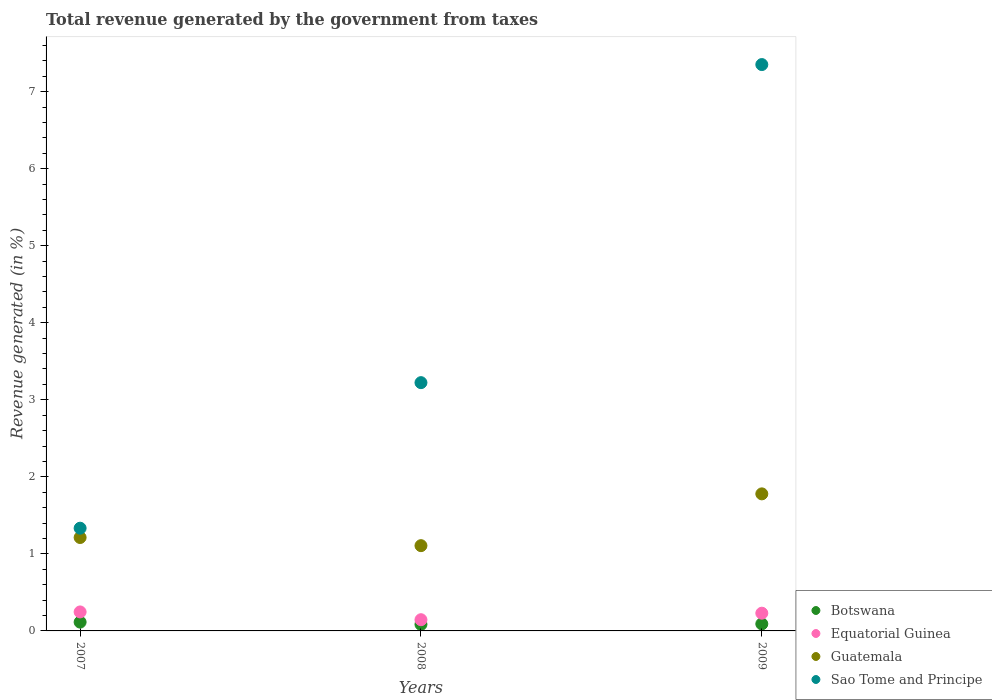Is the number of dotlines equal to the number of legend labels?
Ensure brevity in your answer.  Yes. What is the total revenue generated in Equatorial Guinea in 2008?
Your answer should be compact. 0.15. Across all years, what is the maximum total revenue generated in Equatorial Guinea?
Give a very brief answer. 0.25. Across all years, what is the minimum total revenue generated in Sao Tome and Principe?
Your answer should be very brief. 1.33. In which year was the total revenue generated in Sao Tome and Principe maximum?
Your answer should be very brief. 2009. What is the total total revenue generated in Botswana in the graph?
Offer a terse response. 0.29. What is the difference between the total revenue generated in Botswana in 2008 and that in 2009?
Give a very brief answer. -0.01. What is the difference between the total revenue generated in Guatemala in 2007 and the total revenue generated in Equatorial Guinea in 2009?
Keep it short and to the point. 0.98. What is the average total revenue generated in Sao Tome and Principe per year?
Offer a very short reply. 3.97. In the year 2007, what is the difference between the total revenue generated in Sao Tome and Principe and total revenue generated in Botswana?
Your response must be concise. 1.22. What is the ratio of the total revenue generated in Equatorial Guinea in 2008 to that in 2009?
Make the answer very short. 0.63. Is the total revenue generated in Sao Tome and Principe in 2007 less than that in 2009?
Give a very brief answer. Yes. What is the difference between the highest and the second highest total revenue generated in Botswana?
Provide a succinct answer. 0.02. What is the difference between the highest and the lowest total revenue generated in Sao Tome and Principe?
Your response must be concise. 6.02. In how many years, is the total revenue generated in Equatorial Guinea greater than the average total revenue generated in Equatorial Guinea taken over all years?
Your answer should be very brief. 2. Is the sum of the total revenue generated in Guatemala in 2007 and 2009 greater than the maximum total revenue generated in Equatorial Guinea across all years?
Offer a terse response. Yes. Is it the case that in every year, the sum of the total revenue generated in Guatemala and total revenue generated in Sao Tome and Principe  is greater than the sum of total revenue generated in Equatorial Guinea and total revenue generated in Botswana?
Offer a very short reply. Yes. Is the total revenue generated in Sao Tome and Principe strictly greater than the total revenue generated in Botswana over the years?
Your response must be concise. Yes. What is the difference between two consecutive major ticks on the Y-axis?
Make the answer very short. 1. Where does the legend appear in the graph?
Offer a terse response. Bottom right. How many legend labels are there?
Make the answer very short. 4. What is the title of the graph?
Your response must be concise. Total revenue generated by the government from taxes. Does "Latin America(all income levels)" appear as one of the legend labels in the graph?
Keep it short and to the point. No. What is the label or title of the X-axis?
Give a very brief answer. Years. What is the label or title of the Y-axis?
Ensure brevity in your answer.  Revenue generated (in %). What is the Revenue generated (in %) in Botswana in 2007?
Give a very brief answer. 0.11. What is the Revenue generated (in %) of Equatorial Guinea in 2007?
Give a very brief answer. 0.25. What is the Revenue generated (in %) in Guatemala in 2007?
Ensure brevity in your answer.  1.21. What is the Revenue generated (in %) in Sao Tome and Principe in 2007?
Ensure brevity in your answer.  1.33. What is the Revenue generated (in %) in Botswana in 2008?
Keep it short and to the point. 0.08. What is the Revenue generated (in %) in Equatorial Guinea in 2008?
Offer a very short reply. 0.15. What is the Revenue generated (in %) of Guatemala in 2008?
Make the answer very short. 1.11. What is the Revenue generated (in %) of Sao Tome and Principe in 2008?
Offer a terse response. 3.22. What is the Revenue generated (in %) in Botswana in 2009?
Your response must be concise. 0.09. What is the Revenue generated (in %) in Equatorial Guinea in 2009?
Keep it short and to the point. 0.23. What is the Revenue generated (in %) in Guatemala in 2009?
Offer a very short reply. 1.78. What is the Revenue generated (in %) in Sao Tome and Principe in 2009?
Offer a very short reply. 7.35. Across all years, what is the maximum Revenue generated (in %) in Botswana?
Offer a terse response. 0.11. Across all years, what is the maximum Revenue generated (in %) in Equatorial Guinea?
Provide a short and direct response. 0.25. Across all years, what is the maximum Revenue generated (in %) in Guatemala?
Offer a terse response. 1.78. Across all years, what is the maximum Revenue generated (in %) of Sao Tome and Principe?
Your response must be concise. 7.35. Across all years, what is the minimum Revenue generated (in %) in Botswana?
Your answer should be very brief. 0.08. Across all years, what is the minimum Revenue generated (in %) of Equatorial Guinea?
Offer a very short reply. 0.15. Across all years, what is the minimum Revenue generated (in %) in Guatemala?
Make the answer very short. 1.11. Across all years, what is the minimum Revenue generated (in %) in Sao Tome and Principe?
Make the answer very short. 1.33. What is the total Revenue generated (in %) of Botswana in the graph?
Give a very brief answer. 0.29. What is the total Revenue generated (in %) of Equatorial Guinea in the graph?
Your response must be concise. 0.62. What is the total Revenue generated (in %) of Guatemala in the graph?
Give a very brief answer. 4.1. What is the total Revenue generated (in %) in Sao Tome and Principe in the graph?
Provide a succinct answer. 11.91. What is the difference between the Revenue generated (in %) of Botswana in 2007 and that in 2008?
Provide a succinct answer. 0.03. What is the difference between the Revenue generated (in %) in Equatorial Guinea in 2007 and that in 2008?
Your response must be concise. 0.1. What is the difference between the Revenue generated (in %) of Guatemala in 2007 and that in 2008?
Provide a short and direct response. 0.11. What is the difference between the Revenue generated (in %) in Sao Tome and Principe in 2007 and that in 2008?
Offer a terse response. -1.89. What is the difference between the Revenue generated (in %) of Botswana in 2007 and that in 2009?
Make the answer very short. 0.02. What is the difference between the Revenue generated (in %) in Equatorial Guinea in 2007 and that in 2009?
Keep it short and to the point. 0.02. What is the difference between the Revenue generated (in %) of Guatemala in 2007 and that in 2009?
Make the answer very short. -0.57. What is the difference between the Revenue generated (in %) in Sao Tome and Principe in 2007 and that in 2009?
Provide a short and direct response. -6.02. What is the difference between the Revenue generated (in %) of Botswana in 2008 and that in 2009?
Make the answer very short. -0.01. What is the difference between the Revenue generated (in %) of Equatorial Guinea in 2008 and that in 2009?
Give a very brief answer. -0.08. What is the difference between the Revenue generated (in %) of Guatemala in 2008 and that in 2009?
Offer a terse response. -0.67. What is the difference between the Revenue generated (in %) of Sao Tome and Principe in 2008 and that in 2009?
Provide a short and direct response. -4.13. What is the difference between the Revenue generated (in %) of Botswana in 2007 and the Revenue generated (in %) of Equatorial Guinea in 2008?
Your response must be concise. -0.03. What is the difference between the Revenue generated (in %) in Botswana in 2007 and the Revenue generated (in %) in Guatemala in 2008?
Provide a succinct answer. -0.99. What is the difference between the Revenue generated (in %) of Botswana in 2007 and the Revenue generated (in %) of Sao Tome and Principe in 2008?
Your answer should be compact. -3.11. What is the difference between the Revenue generated (in %) in Equatorial Guinea in 2007 and the Revenue generated (in %) in Guatemala in 2008?
Ensure brevity in your answer.  -0.86. What is the difference between the Revenue generated (in %) in Equatorial Guinea in 2007 and the Revenue generated (in %) in Sao Tome and Principe in 2008?
Offer a terse response. -2.98. What is the difference between the Revenue generated (in %) in Guatemala in 2007 and the Revenue generated (in %) in Sao Tome and Principe in 2008?
Offer a very short reply. -2.01. What is the difference between the Revenue generated (in %) in Botswana in 2007 and the Revenue generated (in %) in Equatorial Guinea in 2009?
Make the answer very short. -0.12. What is the difference between the Revenue generated (in %) of Botswana in 2007 and the Revenue generated (in %) of Guatemala in 2009?
Your response must be concise. -1.66. What is the difference between the Revenue generated (in %) in Botswana in 2007 and the Revenue generated (in %) in Sao Tome and Principe in 2009?
Make the answer very short. -7.24. What is the difference between the Revenue generated (in %) in Equatorial Guinea in 2007 and the Revenue generated (in %) in Guatemala in 2009?
Offer a very short reply. -1.53. What is the difference between the Revenue generated (in %) in Equatorial Guinea in 2007 and the Revenue generated (in %) in Sao Tome and Principe in 2009?
Provide a succinct answer. -7.1. What is the difference between the Revenue generated (in %) of Guatemala in 2007 and the Revenue generated (in %) of Sao Tome and Principe in 2009?
Offer a very short reply. -6.14. What is the difference between the Revenue generated (in %) in Botswana in 2008 and the Revenue generated (in %) in Equatorial Guinea in 2009?
Your response must be concise. -0.15. What is the difference between the Revenue generated (in %) in Botswana in 2008 and the Revenue generated (in %) in Guatemala in 2009?
Your answer should be compact. -1.69. What is the difference between the Revenue generated (in %) in Botswana in 2008 and the Revenue generated (in %) in Sao Tome and Principe in 2009?
Offer a very short reply. -7.27. What is the difference between the Revenue generated (in %) of Equatorial Guinea in 2008 and the Revenue generated (in %) of Guatemala in 2009?
Give a very brief answer. -1.63. What is the difference between the Revenue generated (in %) in Equatorial Guinea in 2008 and the Revenue generated (in %) in Sao Tome and Principe in 2009?
Offer a very short reply. -7.21. What is the difference between the Revenue generated (in %) in Guatemala in 2008 and the Revenue generated (in %) in Sao Tome and Principe in 2009?
Give a very brief answer. -6.24. What is the average Revenue generated (in %) in Botswana per year?
Your answer should be compact. 0.1. What is the average Revenue generated (in %) of Equatorial Guinea per year?
Your answer should be compact. 0.21. What is the average Revenue generated (in %) of Guatemala per year?
Ensure brevity in your answer.  1.37. What is the average Revenue generated (in %) in Sao Tome and Principe per year?
Your answer should be compact. 3.97. In the year 2007, what is the difference between the Revenue generated (in %) of Botswana and Revenue generated (in %) of Equatorial Guinea?
Provide a succinct answer. -0.13. In the year 2007, what is the difference between the Revenue generated (in %) in Botswana and Revenue generated (in %) in Guatemala?
Keep it short and to the point. -1.1. In the year 2007, what is the difference between the Revenue generated (in %) in Botswana and Revenue generated (in %) in Sao Tome and Principe?
Your answer should be compact. -1.22. In the year 2007, what is the difference between the Revenue generated (in %) of Equatorial Guinea and Revenue generated (in %) of Guatemala?
Your answer should be compact. -0.97. In the year 2007, what is the difference between the Revenue generated (in %) of Equatorial Guinea and Revenue generated (in %) of Sao Tome and Principe?
Make the answer very short. -1.09. In the year 2007, what is the difference between the Revenue generated (in %) of Guatemala and Revenue generated (in %) of Sao Tome and Principe?
Ensure brevity in your answer.  -0.12. In the year 2008, what is the difference between the Revenue generated (in %) of Botswana and Revenue generated (in %) of Equatorial Guinea?
Offer a terse response. -0.06. In the year 2008, what is the difference between the Revenue generated (in %) in Botswana and Revenue generated (in %) in Guatemala?
Offer a very short reply. -1.02. In the year 2008, what is the difference between the Revenue generated (in %) of Botswana and Revenue generated (in %) of Sao Tome and Principe?
Your answer should be very brief. -3.14. In the year 2008, what is the difference between the Revenue generated (in %) of Equatorial Guinea and Revenue generated (in %) of Guatemala?
Offer a very short reply. -0.96. In the year 2008, what is the difference between the Revenue generated (in %) in Equatorial Guinea and Revenue generated (in %) in Sao Tome and Principe?
Make the answer very short. -3.08. In the year 2008, what is the difference between the Revenue generated (in %) of Guatemala and Revenue generated (in %) of Sao Tome and Principe?
Ensure brevity in your answer.  -2.12. In the year 2009, what is the difference between the Revenue generated (in %) in Botswana and Revenue generated (in %) in Equatorial Guinea?
Your response must be concise. -0.14. In the year 2009, what is the difference between the Revenue generated (in %) of Botswana and Revenue generated (in %) of Guatemala?
Keep it short and to the point. -1.69. In the year 2009, what is the difference between the Revenue generated (in %) in Botswana and Revenue generated (in %) in Sao Tome and Principe?
Offer a terse response. -7.26. In the year 2009, what is the difference between the Revenue generated (in %) in Equatorial Guinea and Revenue generated (in %) in Guatemala?
Your answer should be compact. -1.55. In the year 2009, what is the difference between the Revenue generated (in %) in Equatorial Guinea and Revenue generated (in %) in Sao Tome and Principe?
Provide a succinct answer. -7.12. In the year 2009, what is the difference between the Revenue generated (in %) in Guatemala and Revenue generated (in %) in Sao Tome and Principe?
Offer a very short reply. -5.57. What is the ratio of the Revenue generated (in %) of Botswana in 2007 to that in 2008?
Offer a very short reply. 1.35. What is the ratio of the Revenue generated (in %) in Equatorial Guinea in 2007 to that in 2008?
Keep it short and to the point. 1.69. What is the ratio of the Revenue generated (in %) in Guatemala in 2007 to that in 2008?
Provide a succinct answer. 1.1. What is the ratio of the Revenue generated (in %) of Sao Tome and Principe in 2007 to that in 2008?
Give a very brief answer. 0.41. What is the ratio of the Revenue generated (in %) in Botswana in 2007 to that in 2009?
Provide a succinct answer. 1.25. What is the ratio of the Revenue generated (in %) of Equatorial Guinea in 2007 to that in 2009?
Keep it short and to the point. 1.07. What is the ratio of the Revenue generated (in %) in Guatemala in 2007 to that in 2009?
Ensure brevity in your answer.  0.68. What is the ratio of the Revenue generated (in %) in Sao Tome and Principe in 2007 to that in 2009?
Provide a succinct answer. 0.18. What is the ratio of the Revenue generated (in %) of Botswana in 2008 to that in 2009?
Ensure brevity in your answer.  0.93. What is the ratio of the Revenue generated (in %) in Equatorial Guinea in 2008 to that in 2009?
Provide a succinct answer. 0.63. What is the ratio of the Revenue generated (in %) of Guatemala in 2008 to that in 2009?
Your answer should be very brief. 0.62. What is the ratio of the Revenue generated (in %) in Sao Tome and Principe in 2008 to that in 2009?
Provide a short and direct response. 0.44. What is the difference between the highest and the second highest Revenue generated (in %) in Botswana?
Provide a short and direct response. 0.02. What is the difference between the highest and the second highest Revenue generated (in %) of Equatorial Guinea?
Your response must be concise. 0.02. What is the difference between the highest and the second highest Revenue generated (in %) in Guatemala?
Offer a terse response. 0.57. What is the difference between the highest and the second highest Revenue generated (in %) in Sao Tome and Principe?
Offer a very short reply. 4.13. What is the difference between the highest and the lowest Revenue generated (in %) of Botswana?
Provide a succinct answer. 0.03. What is the difference between the highest and the lowest Revenue generated (in %) of Equatorial Guinea?
Provide a succinct answer. 0.1. What is the difference between the highest and the lowest Revenue generated (in %) of Guatemala?
Keep it short and to the point. 0.67. What is the difference between the highest and the lowest Revenue generated (in %) in Sao Tome and Principe?
Provide a succinct answer. 6.02. 